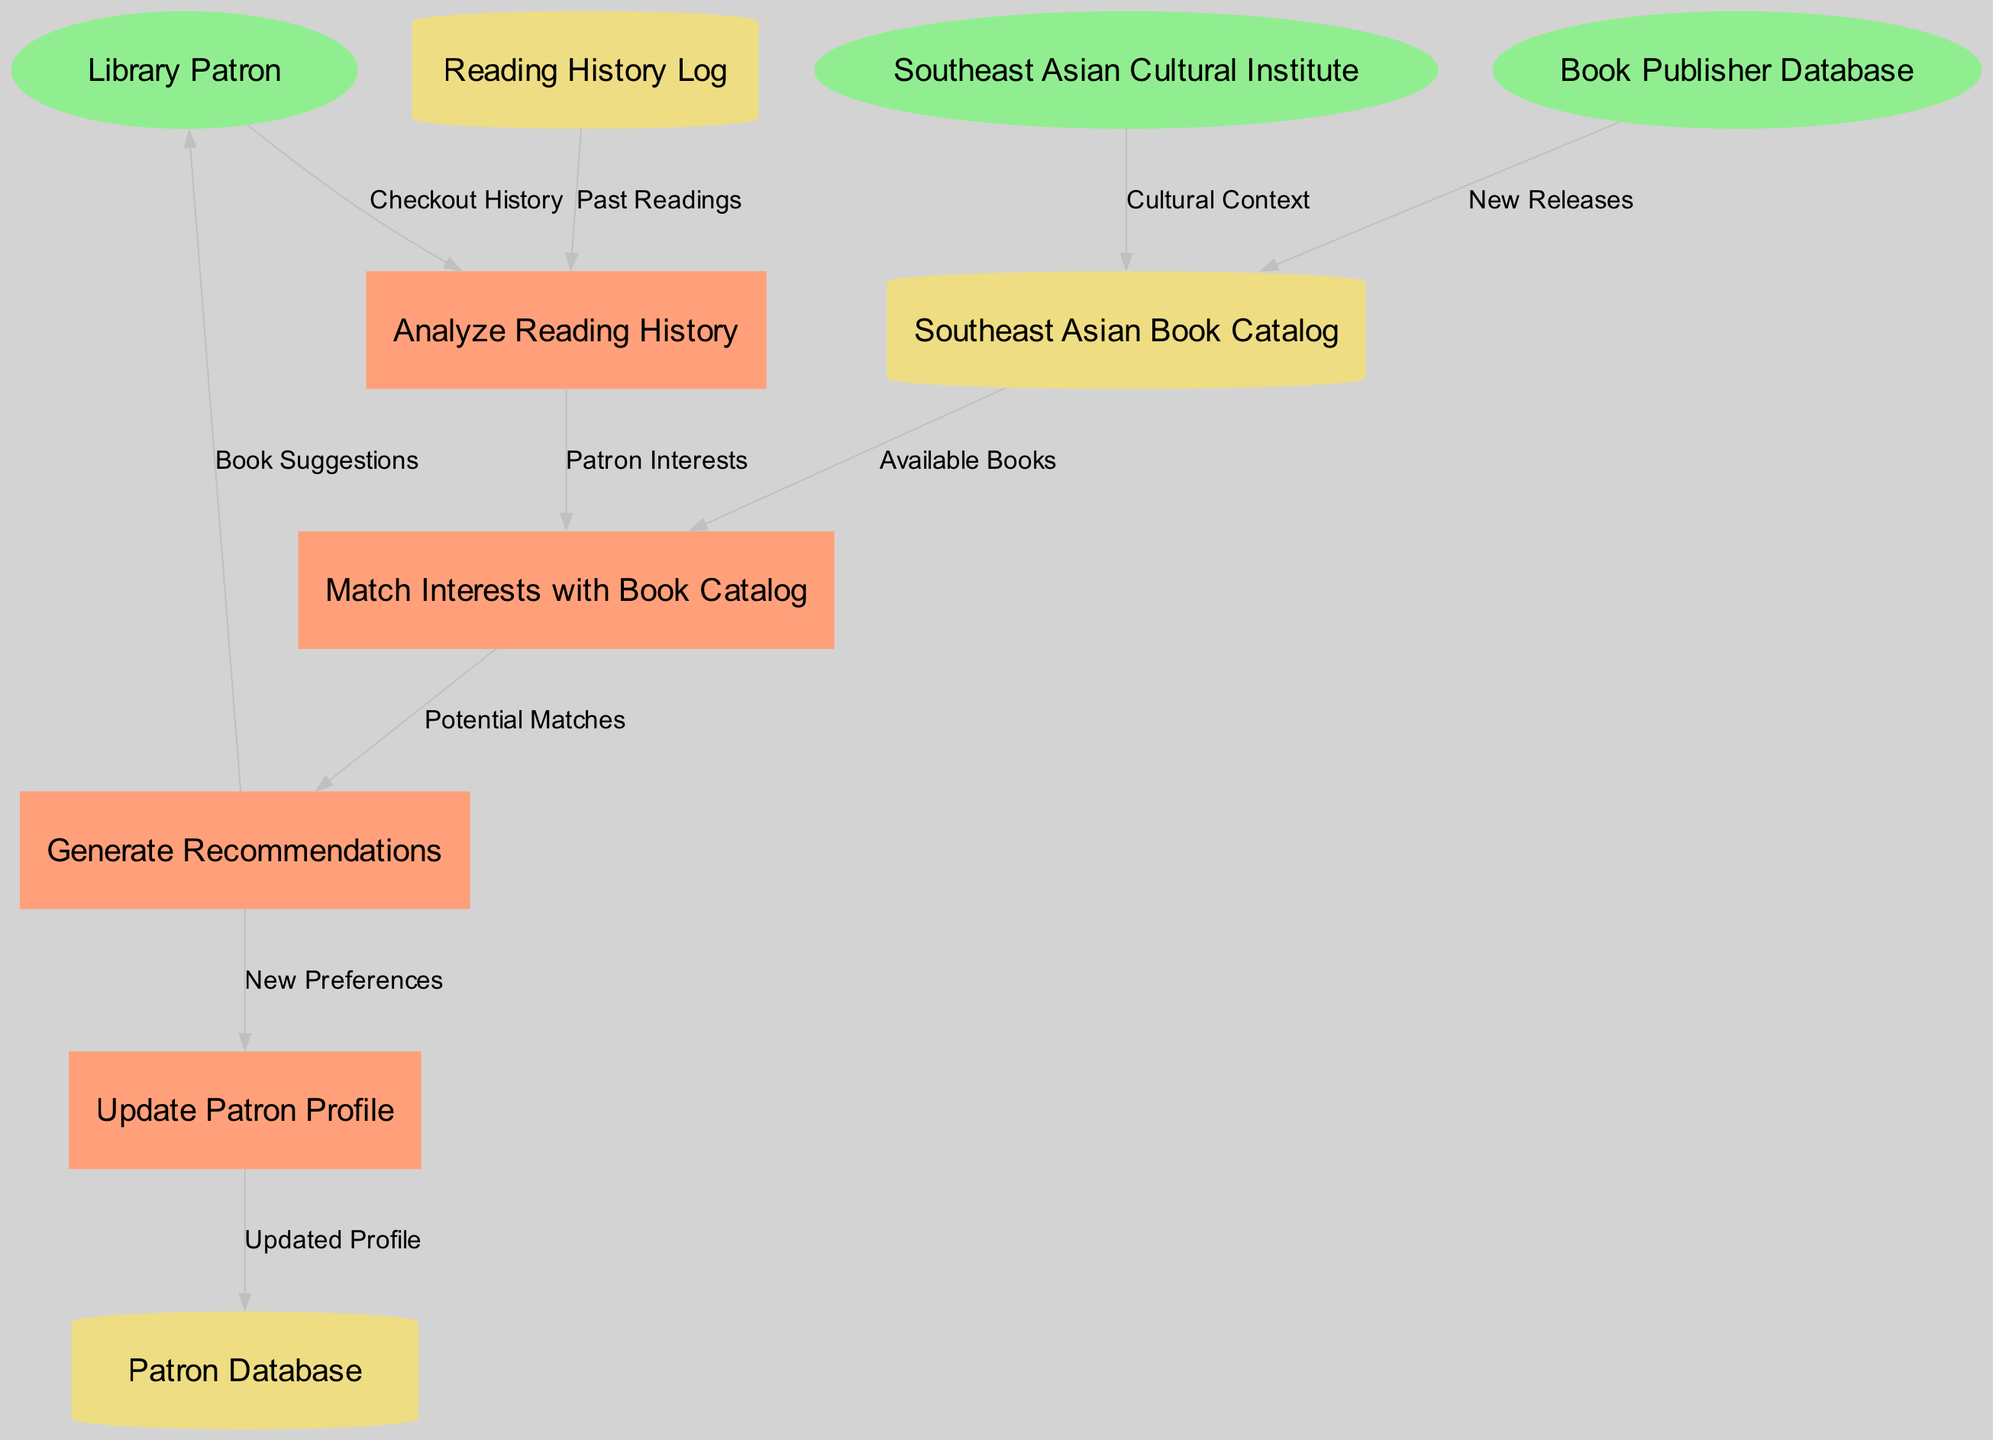What are the external entities in this diagram? The external entities include "Library Patron", "Book Publisher Database", and "Southeast Asian Cultural Institute". These are represented as oval shapes in the diagram, indicating they are sources of input or recipients of output within the system.
Answer: Library Patron, Book Publisher Database, Southeast Asian Cultural Institute How many processes are represented in the diagram? There are four processes included in the diagram: "Analyze Reading History", "Match Interests with Book Catalog", "Generate Recommendations", and "Update Patron Profile". Counting the rectangles representing processes gives the total number.
Answer: 4 What data flow connects the Library Patron to the Analyze Reading History process? The data flow from "Library Patron" to "Analyze Reading History" is labeled "Checkout History". This indicates that the patron's checkout history is used as input for analyzing their reading history.
Answer: Checkout History What does the Update Patron Profile process output? The "Update Patron Profile" process outputs "Updated Profile" which flows into the "Patron Database". This implies that the updated preferences from the patron are stored in their profile within the database.
Answer: Updated Profile Which process receives the "Potential Matches" data flow? The "Generate Recommendations" process receives the "Potential Matches" data flow from the "Match Interests with Book Catalog" process. This implies that it uses the matched interests to generate book recommendations.
Answer: Generate Recommendations What is the role of the Southeast Asian Cultural Institute in the diagram? The Southeast Asian Cultural Institute provides "Cultural Context" to the "Southeast Asian Book Catalog". This indicates that cultural insights are integrated into the book catalog for better recommendations.
Answer: Cultural Context How many data stores are included in the diagram? There are three data stores shown in the diagram: "Patron Database", "Southeast Asian Book Catalog", and "Reading History Log". The count of cylindrical shapes indicates the number of data stores.
Answer: 3 Which external entity provides "New Releases" to the Southeast Asian Book Catalog? The "Book Publisher Database" provides "New Releases" to the "Southeast Asian Book Catalog". This relationship shows a flow of new publication information into the catalog for potential recommendations.
Answer: Book Publisher Database What is the flow direction of the data from "Reading History Log"? The data flows from "Reading History Log" to "Analyze Reading History", indicating that the past readings recorded in the log are utilized to analyze the patron's reading history.
Answer: To Analyze Reading History 